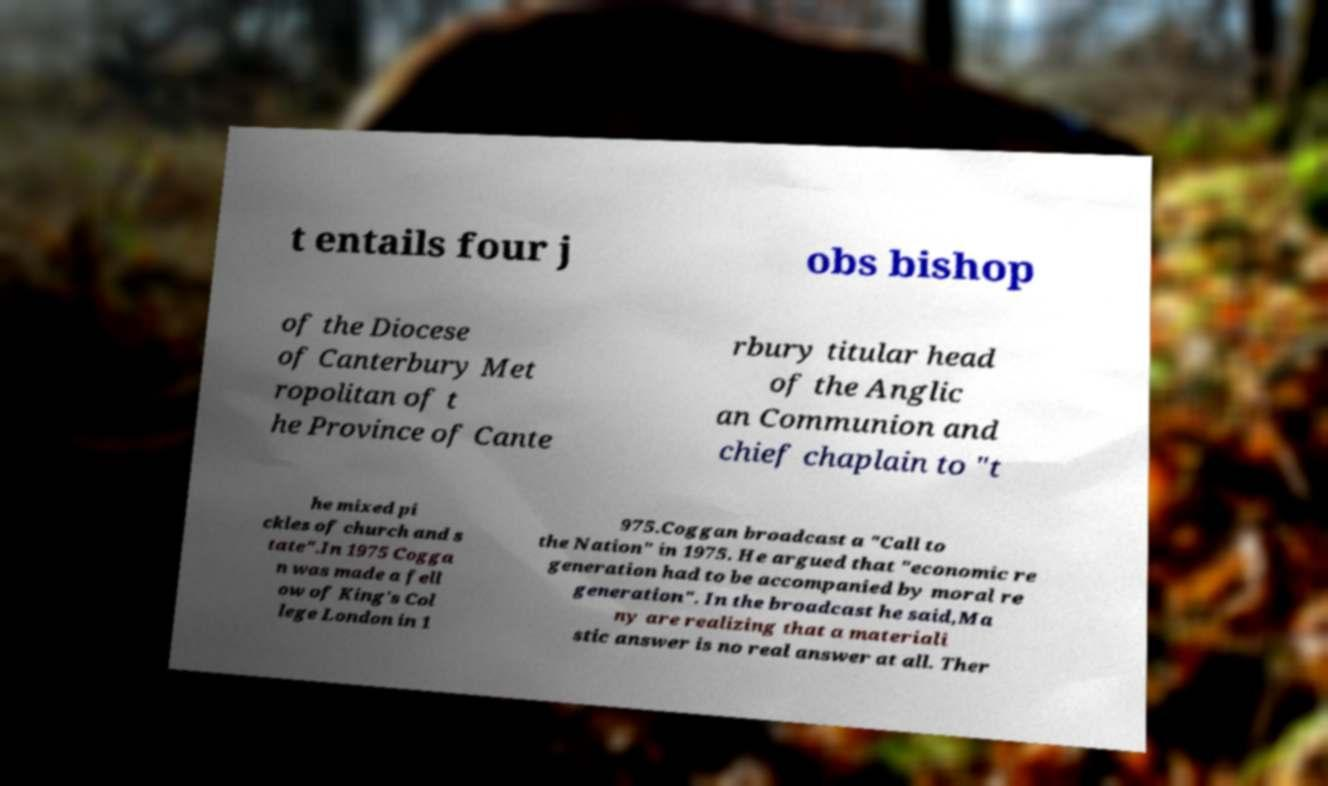Can you read and provide the text displayed in the image?This photo seems to have some interesting text. Can you extract and type it out for me? t entails four j obs bishop of the Diocese of Canterbury Met ropolitan of t he Province of Cante rbury titular head of the Anglic an Communion and chief chaplain to "t he mixed pi ckles of church and s tate".In 1975 Cogga n was made a fell ow of King's Col lege London in 1 975.Coggan broadcast a "Call to the Nation" in 1975. He argued that "economic re generation had to be accompanied by moral re generation". In the broadcast he said,Ma ny are realizing that a materiali stic answer is no real answer at all. Ther 